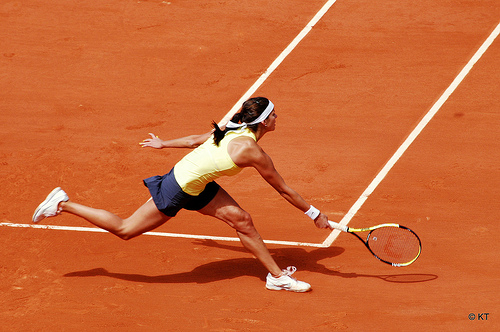Describe the intensity of the action captured in the image. The image captures a high intensity moment within a tennis match, exhibiting great agility and focus as the player stretches fully to reach the ball. Can you talk more about her positioning and motion? Certainly! The player's form shows dynamic movement, with excellent balance and a powerful leg stretch, indicating a strong follow-through needed for her backhand shot. 